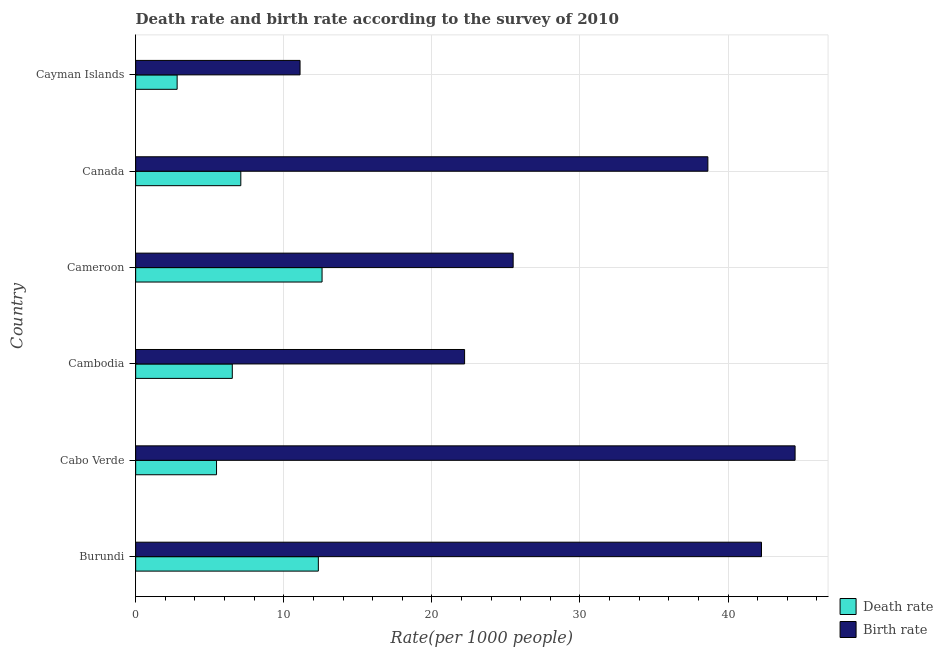How many different coloured bars are there?
Your response must be concise. 2. How many groups of bars are there?
Give a very brief answer. 6. Are the number of bars per tick equal to the number of legend labels?
Your response must be concise. Yes. Are the number of bars on each tick of the Y-axis equal?
Your answer should be compact. Yes. What is the label of the 3rd group of bars from the top?
Provide a succinct answer. Cameroon. What is the birth rate in Cambodia?
Your response must be concise. 22.21. Across all countries, what is the maximum birth rate?
Offer a very short reply. 44.53. In which country was the death rate maximum?
Provide a short and direct response. Cameroon. In which country was the death rate minimum?
Your answer should be very brief. Cayman Islands. What is the total death rate in the graph?
Give a very brief answer. 46.81. What is the difference between the death rate in Burundi and that in Cambodia?
Offer a terse response. 5.81. What is the difference between the death rate in Canada and the birth rate in Cabo Verde?
Your answer should be very brief. -37.43. What is the average birth rate per country?
Give a very brief answer. 30.71. What is the difference between the death rate and birth rate in Cabo Verde?
Offer a very short reply. -39.07. In how many countries, is the death rate greater than 12 ?
Your response must be concise. 2. What is the ratio of the birth rate in Cabo Verde to that in Cameroon?
Make the answer very short. 1.75. What is the difference between the highest and the second highest death rate?
Ensure brevity in your answer.  0.25. What is the difference between the highest and the lowest birth rate?
Provide a short and direct response. 33.43. Is the sum of the death rate in Burundi and Cabo Verde greater than the maximum birth rate across all countries?
Provide a short and direct response. No. What does the 1st bar from the top in Burundi represents?
Provide a short and direct response. Birth rate. What does the 1st bar from the bottom in Cameroon represents?
Provide a succinct answer. Death rate. How many bars are there?
Your answer should be very brief. 12. Are all the bars in the graph horizontal?
Provide a succinct answer. Yes. What is the difference between two consecutive major ticks on the X-axis?
Your answer should be compact. 10. Does the graph contain grids?
Provide a short and direct response. Yes. Where does the legend appear in the graph?
Your answer should be compact. Bottom right. How many legend labels are there?
Provide a succinct answer. 2. How are the legend labels stacked?
Offer a very short reply. Vertical. What is the title of the graph?
Provide a short and direct response. Death rate and birth rate according to the survey of 2010. What is the label or title of the X-axis?
Give a very brief answer. Rate(per 1000 people). What is the Rate(per 1000 people) of Death rate in Burundi?
Your response must be concise. 12.34. What is the Rate(per 1000 people) of Birth rate in Burundi?
Offer a terse response. 42.26. What is the Rate(per 1000 people) of Death rate in Cabo Verde?
Provide a succinct answer. 5.46. What is the Rate(per 1000 people) in Birth rate in Cabo Verde?
Provide a succinct answer. 44.53. What is the Rate(per 1000 people) in Death rate in Cambodia?
Offer a terse response. 6.53. What is the Rate(per 1000 people) of Birth rate in Cambodia?
Keep it short and to the point. 22.21. What is the Rate(per 1000 people) in Death rate in Cameroon?
Give a very brief answer. 12.59. What is the Rate(per 1000 people) in Birth rate in Cameroon?
Your response must be concise. 25.49. What is the Rate(per 1000 people) in Death rate in Canada?
Your response must be concise. 7.1. What is the Rate(per 1000 people) in Birth rate in Canada?
Offer a very short reply. 38.64. Across all countries, what is the maximum Rate(per 1000 people) in Death rate?
Your response must be concise. 12.59. Across all countries, what is the maximum Rate(per 1000 people) of Birth rate?
Give a very brief answer. 44.53. Across all countries, what is the minimum Rate(per 1000 people) in Death rate?
Provide a succinct answer. 2.8. Across all countries, what is the minimum Rate(per 1000 people) of Birth rate?
Make the answer very short. 11.1. What is the total Rate(per 1000 people) of Death rate in the graph?
Ensure brevity in your answer.  46.81. What is the total Rate(per 1000 people) in Birth rate in the graph?
Give a very brief answer. 184.23. What is the difference between the Rate(per 1000 people) in Death rate in Burundi and that in Cabo Verde?
Offer a very short reply. 6.88. What is the difference between the Rate(per 1000 people) of Birth rate in Burundi and that in Cabo Verde?
Offer a very short reply. -2.27. What is the difference between the Rate(per 1000 people) in Death rate in Burundi and that in Cambodia?
Give a very brief answer. 5.81. What is the difference between the Rate(per 1000 people) in Birth rate in Burundi and that in Cambodia?
Offer a very short reply. 20.05. What is the difference between the Rate(per 1000 people) of Death rate in Burundi and that in Cameroon?
Keep it short and to the point. -0.25. What is the difference between the Rate(per 1000 people) in Birth rate in Burundi and that in Cameroon?
Keep it short and to the point. 16.77. What is the difference between the Rate(per 1000 people) in Death rate in Burundi and that in Canada?
Offer a terse response. 5.24. What is the difference between the Rate(per 1000 people) in Birth rate in Burundi and that in Canada?
Your answer should be compact. 3.62. What is the difference between the Rate(per 1000 people) in Death rate in Burundi and that in Cayman Islands?
Make the answer very short. 9.54. What is the difference between the Rate(per 1000 people) of Birth rate in Burundi and that in Cayman Islands?
Your answer should be very brief. 31.16. What is the difference between the Rate(per 1000 people) of Death rate in Cabo Verde and that in Cambodia?
Keep it short and to the point. -1.06. What is the difference between the Rate(per 1000 people) in Birth rate in Cabo Verde and that in Cambodia?
Give a very brief answer. 22.32. What is the difference between the Rate(per 1000 people) of Death rate in Cabo Verde and that in Cameroon?
Your answer should be very brief. -7.13. What is the difference between the Rate(per 1000 people) in Birth rate in Cabo Verde and that in Cameroon?
Provide a short and direct response. 19.04. What is the difference between the Rate(per 1000 people) in Death rate in Cabo Verde and that in Canada?
Your answer should be very brief. -1.64. What is the difference between the Rate(per 1000 people) in Birth rate in Cabo Verde and that in Canada?
Provide a succinct answer. 5.89. What is the difference between the Rate(per 1000 people) in Death rate in Cabo Verde and that in Cayman Islands?
Provide a succinct answer. 2.66. What is the difference between the Rate(per 1000 people) of Birth rate in Cabo Verde and that in Cayman Islands?
Ensure brevity in your answer.  33.43. What is the difference between the Rate(per 1000 people) in Death rate in Cambodia and that in Cameroon?
Ensure brevity in your answer.  -6.06. What is the difference between the Rate(per 1000 people) in Birth rate in Cambodia and that in Cameroon?
Provide a succinct answer. -3.28. What is the difference between the Rate(per 1000 people) in Death rate in Cambodia and that in Canada?
Your answer should be very brief. -0.57. What is the difference between the Rate(per 1000 people) in Birth rate in Cambodia and that in Canada?
Offer a very short reply. -16.43. What is the difference between the Rate(per 1000 people) of Death rate in Cambodia and that in Cayman Islands?
Offer a very short reply. 3.73. What is the difference between the Rate(per 1000 people) of Birth rate in Cambodia and that in Cayman Islands?
Give a very brief answer. 11.11. What is the difference between the Rate(per 1000 people) of Death rate in Cameroon and that in Canada?
Your answer should be compact. 5.49. What is the difference between the Rate(per 1000 people) of Birth rate in Cameroon and that in Canada?
Keep it short and to the point. -13.15. What is the difference between the Rate(per 1000 people) in Death rate in Cameroon and that in Cayman Islands?
Provide a succinct answer. 9.79. What is the difference between the Rate(per 1000 people) in Birth rate in Cameroon and that in Cayman Islands?
Keep it short and to the point. 14.39. What is the difference between the Rate(per 1000 people) of Death rate in Canada and that in Cayman Islands?
Offer a very short reply. 4.3. What is the difference between the Rate(per 1000 people) of Birth rate in Canada and that in Cayman Islands?
Give a very brief answer. 27.54. What is the difference between the Rate(per 1000 people) of Death rate in Burundi and the Rate(per 1000 people) of Birth rate in Cabo Verde?
Give a very brief answer. -32.19. What is the difference between the Rate(per 1000 people) of Death rate in Burundi and the Rate(per 1000 people) of Birth rate in Cambodia?
Your response must be concise. -9.88. What is the difference between the Rate(per 1000 people) in Death rate in Burundi and the Rate(per 1000 people) in Birth rate in Cameroon?
Ensure brevity in your answer.  -13.15. What is the difference between the Rate(per 1000 people) of Death rate in Burundi and the Rate(per 1000 people) of Birth rate in Canada?
Offer a very short reply. -26.3. What is the difference between the Rate(per 1000 people) of Death rate in Burundi and the Rate(per 1000 people) of Birth rate in Cayman Islands?
Offer a terse response. 1.24. What is the difference between the Rate(per 1000 people) in Death rate in Cabo Verde and the Rate(per 1000 people) in Birth rate in Cambodia?
Keep it short and to the point. -16.75. What is the difference between the Rate(per 1000 people) in Death rate in Cabo Verde and the Rate(per 1000 people) in Birth rate in Cameroon?
Make the answer very short. -20.03. What is the difference between the Rate(per 1000 people) in Death rate in Cabo Verde and the Rate(per 1000 people) in Birth rate in Canada?
Provide a succinct answer. -33.18. What is the difference between the Rate(per 1000 people) in Death rate in Cabo Verde and the Rate(per 1000 people) in Birth rate in Cayman Islands?
Keep it short and to the point. -5.64. What is the difference between the Rate(per 1000 people) of Death rate in Cambodia and the Rate(per 1000 people) of Birth rate in Cameroon?
Your answer should be compact. -18.97. What is the difference between the Rate(per 1000 people) in Death rate in Cambodia and the Rate(per 1000 people) in Birth rate in Canada?
Provide a short and direct response. -32.12. What is the difference between the Rate(per 1000 people) of Death rate in Cambodia and the Rate(per 1000 people) of Birth rate in Cayman Islands?
Keep it short and to the point. -4.58. What is the difference between the Rate(per 1000 people) of Death rate in Cameroon and the Rate(per 1000 people) of Birth rate in Canada?
Provide a succinct answer. -26.05. What is the difference between the Rate(per 1000 people) in Death rate in Cameroon and the Rate(per 1000 people) in Birth rate in Cayman Islands?
Provide a short and direct response. 1.49. What is the difference between the Rate(per 1000 people) of Death rate in Canada and the Rate(per 1000 people) of Birth rate in Cayman Islands?
Your response must be concise. -4. What is the average Rate(per 1000 people) of Death rate per country?
Offer a terse response. 7.8. What is the average Rate(per 1000 people) in Birth rate per country?
Make the answer very short. 30.71. What is the difference between the Rate(per 1000 people) in Death rate and Rate(per 1000 people) in Birth rate in Burundi?
Offer a terse response. -29.93. What is the difference between the Rate(per 1000 people) of Death rate and Rate(per 1000 people) of Birth rate in Cabo Verde?
Make the answer very short. -39.07. What is the difference between the Rate(per 1000 people) of Death rate and Rate(per 1000 people) of Birth rate in Cambodia?
Ensure brevity in your answer.  -15.69. What is the difference between the Rate(per 1000 people) of Death rate and Rate(per 1000 people) of Birth rate in Cameroon?
Make the answer very short. -12.9. What is the difference between the Rate(per 1000 people) of Death rate and Rate(per 1000 people) of Birth rate in Canada?
Your response must be concise. -31.54. What is the ratio of the Rate(per 1000 people) of Death rate in Burundi to that in Cabo Verde?
Ensure brevity in your answer.  2.26. What is the ratio of the Rate(per 1000 people) in Birth rate in Burundi to that in Cabo Verde?
Provide a succinct answer. 0.95. What is the ratio of the Rate(per 1000 people) in Death rate in Burundi to that in Cambodia?
Offer a terse response. 1.89. What is the ratio of the Rate(per 1000 people) in Birth rate in Burundi to that in Cambodia?
Your response must be concise. 1.9. What is the ratio of the Rate(per 1000 people) in Death rate in Burundi to that in Cameroon?
Keep it short and to the point. 0.98. What is the ratio of the Rate(per 1000 people) of Birth rate in Burundi to that in Cameroon?
Your answer should be very brief. 1.66. What is the ratio of the Rate(per 1000 people) in Death rate in Burundi to that in Canada?
Provide a succinct answer. 1.74. What is the ratio of the Rate(per 1000 people) in Birth rate in Burundi to that in Canada?
Offer a very short reply. 1.09. What is the ratio of the Rate(per 1000 people) of Death rate in Burundi to that in Cayman Islands?
Offer a very short reply. 4.41. What is the ratio of the Rate(per 1000 people) of Birth rate in Burundi to that in Cayman Islands?
Offer a terse response. 3.81. What is the ratio of the Rate(per 1000 people) in Death rate in Cabo Verde to that in Cambodia?
Provide a succinct answer. 0.84. What is the ratio of the Rate(per 1000 people) in Birth rate in Cabo Verde to that in Cambodia?
Give a very brief answer. 2. What is the ratio of the Rate(per 1000 people) of Death rate in Cabo Verde to that in Cameroon?
Your answer should be very brief. 0.43. What is the ratio of the Rate(per 1000 people) in Birth rate in Cabo Verde to that in Cameroon?
Provide a short and direct response. 1.75. What is the ratio of the Rate(per 1000 people) in Death rate in Cabo Verde to that in Canada?
Give a very brief answer. 0.77. What is the ratio of the Rate(per 1000 people) of Birth rate in Cabo Verde to that in Canada?
Make the answer very short. 1.15. What is the ratio of the Rate(per 1000 people) of Death rate in Cabo Verde to that in Cayman Islands?
Make the answer very short. 1.95. What is the ratio of the Rate(per 1000 people) in Birth rate in Cabo Verde to that in Cayman Islands?
Provide a short and direct response. 4.01. What is the ratio of the Rate(per 1000 people) of Death rate in Cambodia to that in Cameroon?
Offer a terse response. 0.52. What is the ratio of the Rate(per 1000 people) in Birth rate in Cambodia to that in Cameroon?
Keep it short and to the point. 0.87. What is the ratio of the Rate(per 1000 people) of Death rate in Cambodia to that in Canada?
Your answer should be compact. 0.92. What is the ratio of the Rate(per 1000 people) of Birth rate in Cambodia to that in Canada?
Offer a terse response. 0.57. What is the ratio of the Rate(per 1000 people) in Death rate in Cambodia to that in Cayman Islands?
Provide a short and direct response. 2.33. What is the ratio of the Rate(per 1000 people) of Birth rate in Cambodia to that in Cayman Islands?
Ensure brevity in your answer.  2. What is the ratio of the Rate(per 1000 people) in Death rate in Cameroon to that in Canada?
Make the answer very short. 1.77. What is the ratio of the Rate(per 1000 people) in Birth rate in Cameroon to that in Canada?
Provide a short and direct response. 0.66. What is the ratio of the Rate(per 1000 people) of Death rate in Cameroon to that in Cayman Islands?
Offer a terse response. 4.5. What is the ratio of the Rate(per 1000 people) in Birth rate in Cameroon to that in Cayman Islands?
Make the answer very short. 2.3. What is the ratio of the Rate(per 1000 people) of Death rate in Canada to that in Cayman Islands?
Offer a very short reply. 2.54. What is the ratio of the Rate(per 1000 people) in Birth rate in Canada to that in Cayman Islands?
Your response must be concise. 3.48. What is the difference between the highest and the second highest Rate(per 1000 people) of Death rate?
Offer a terse response. 0.25. What is the difference between the highest and the second highest Rate(per 1000 people) of Birth rate?
Your response must be concise. 2.27. What is the difference between the highest and the lowest Rate(per 1000 people) of Death rate?
Offer a terse response. 9.79. What is the difference between the highest and the lowest Rate(per 1000 people) of Birth rate?
Keep it short and to the point. 33.43. 